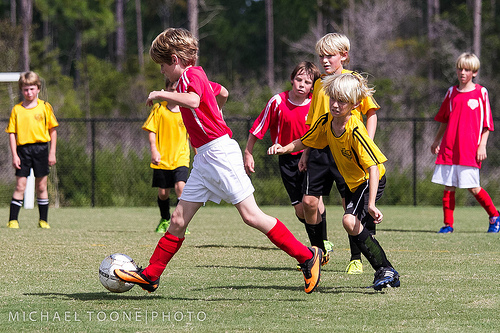<image>
Is there a shirt on the boy? No. The shirt is not positioned on the boy. They may be near each other, but the shirt is not supported by or resting on top of the boy. 